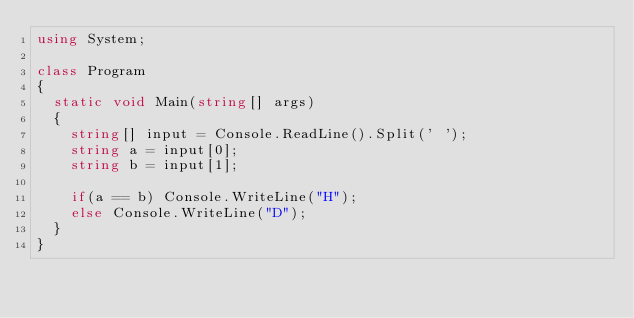<code> <loc_0><loc_0><loc_500><loc_500><_C#_>using System;

class Program
{
  static void Main(string[] args)
  {
    string[] input = Console.ReadLine().Split(' ');
    string a = input[0];
    string b = input[1];
    
    if(a == b) Console.WriteLine("H");
    else Console.WriteLine("D");
  }
}</code> 